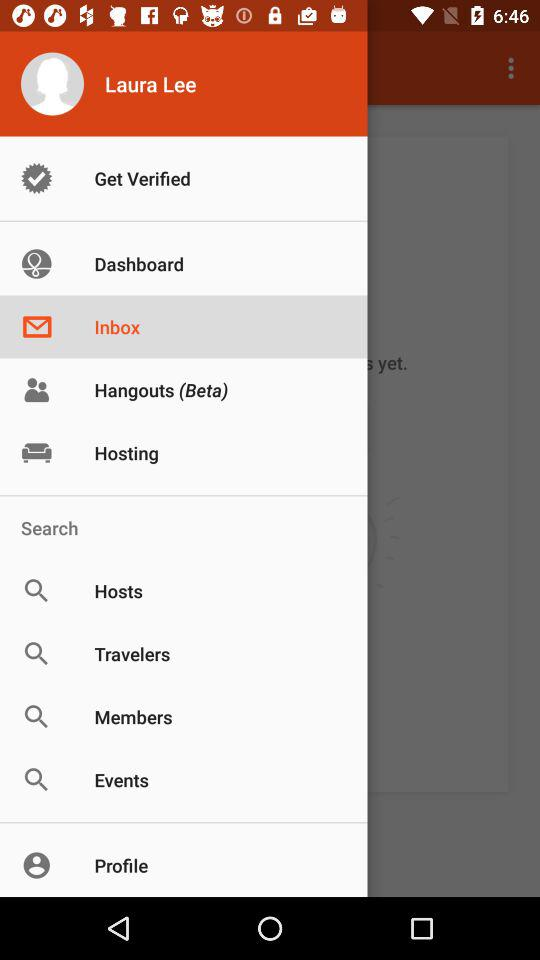Which option has been selected? The selected option is "Inbox". 